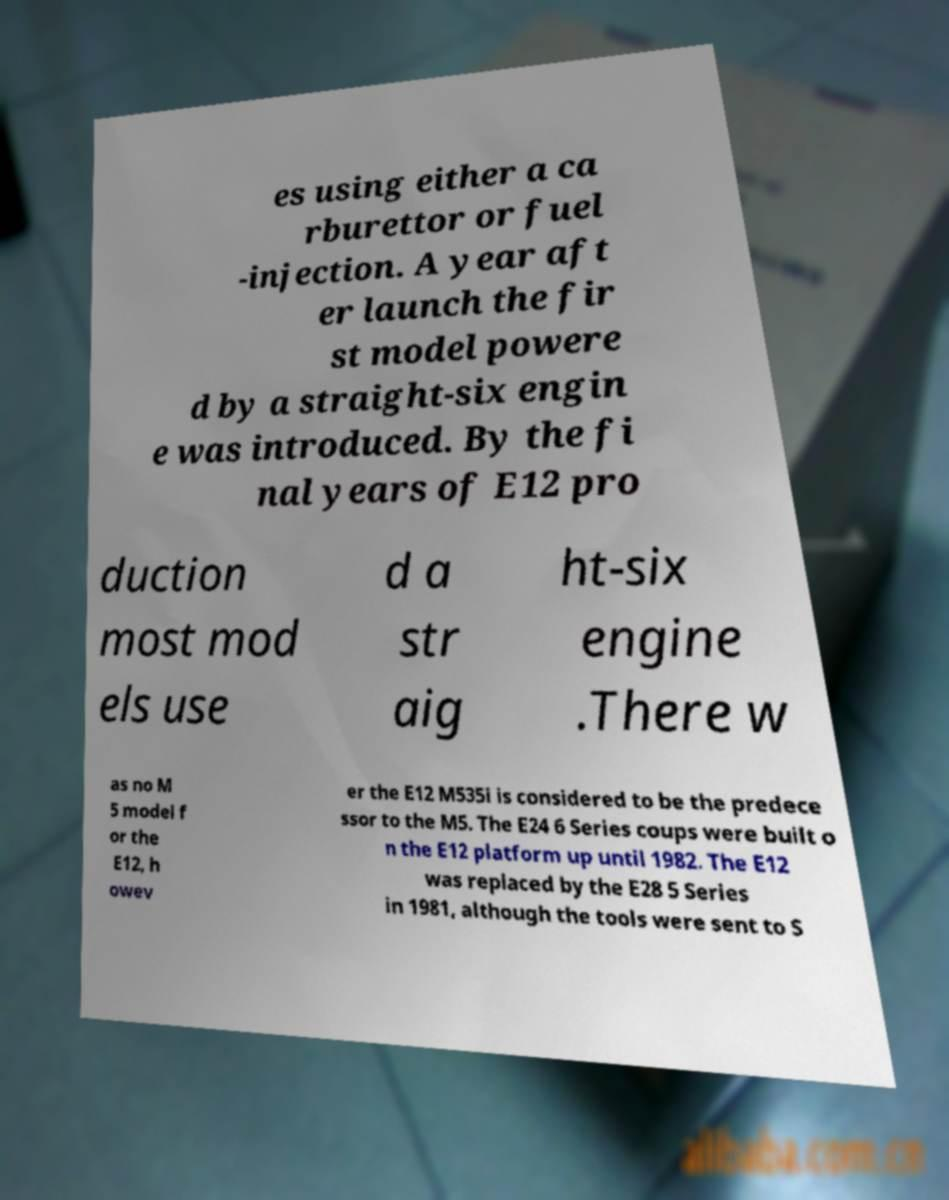Can you accurately transcribe the text from the provided image for me? es using either a ca rburettor or fuel -injection. A year aft er launch the fir st model powere d by a straight-six engin e was introduced. By the fi nal years of E12 pro duction most mod els use d a str aig ht-six engine .There w as no M 5 model f or the E12, h owev er the E12 M535i is considered to be the predece ssor to the M5. The E24 6 Series coups were built o n the E12 platform up until 1982. The E12 was replaced by the E28 5 Series in 1981, although the tools were sent to S 